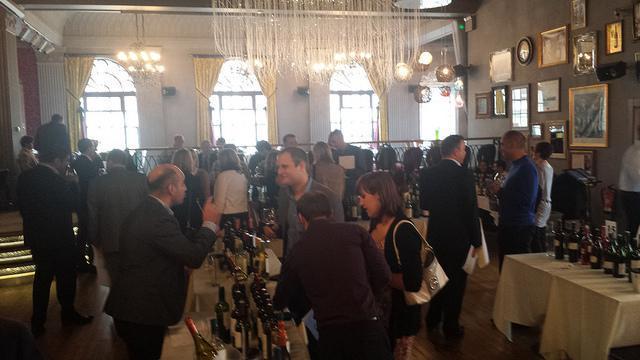How many people can be seen?
Give a very brief answer. 10. 